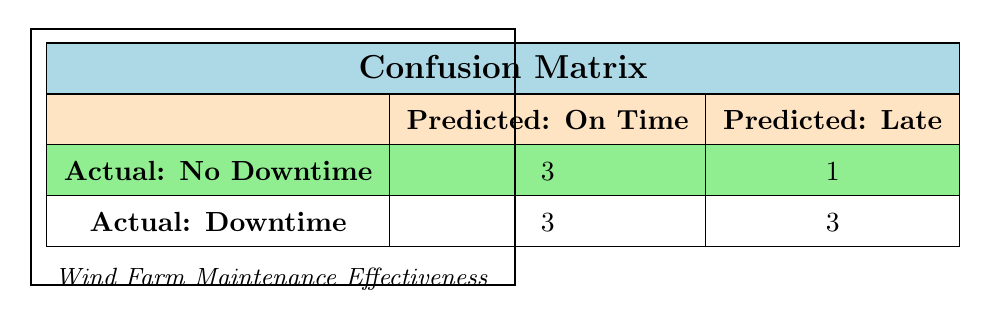What is the total number of wind farms with no downtime? In the table, there are three entries where the actual downtime is "No" (Sunny Ridge Wind Farm, River Valley Wind Farm, and Windy Hill Wind Farm). Therefore, the total number of wind farms with no downtime is 3.
Answer: 3 How many wind farms had their maintenance scheduled on time while experiencing downtime? The table shows three entries with "On Time" for scheduled maintenance and "Yes" for actual downtime (Green Energy Wind Farm, Mountain Peak Wind Farm, and Crystal Lake Wind Farm). Thus, there are 3 such wind farms.
Answer: 3 What is the difference in the number of actual downtimes between farms that had on-time versus late maintenance? There are 3 farms with on-time maintenance and downtime (3), and 3 farms with late maintenance also having downtime (3). The difference is 3 - 3 = 0.
Answer: 0 Was there any wind farm that had late maintenance and still had no downtime? By looking at the table, Silver Lake Wind Farm is the only entry with "Late" maintenance and "No" downtime. Therefore, the answer is yes, there was one such wind farm.
Answer: Yes What percentage of wind farms with late maintenance experienced downtime? There are 3 farms with late maintenance that had downtime (Coastal Breeze Wind Farm, Pine View Wind Farm, Desert Wind Farm) and 2 farms that had late maintenance without downtime (Silver Lake Wind Farm). That is a total of 3 + 2 = 5 farms. The percentage of farms with late maintenance experiencing downtime is (3/5) * 100 = 60%.
Answer: 60% How many total outcomes showed success in maintaining schedules? From the table, the successful outcomes are 3 (Sunny Ridge Wind Farm, River Valley Wind Farm, and Windy Hill Wind Farm). Each of these has "No" downtime. Therefore, the total successful outcomes are 3.
Answer: 3 Is it true that all wind farms with actual downtime had their maintenance scheduled late? We can see from the table that while there are 3 farms with "Late" scheduled maintenance that experienced downtime, there are also 3 with "On Time" scheduled maintenance that had downtime. Therefore, the statement is false.
Answer: No What is the ratio of success to failure among the wind farms listed? The total number of failures is 6 (from failures looking for actual downtime) and successes are 4. Thus, the ratio of success to failure is 4:6, which simplifies to 2:3.
Answer: 2:3 